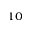<formula> <loc_0><loc_0><loc_500><loc_500>^ { 1 0 }</formula> 